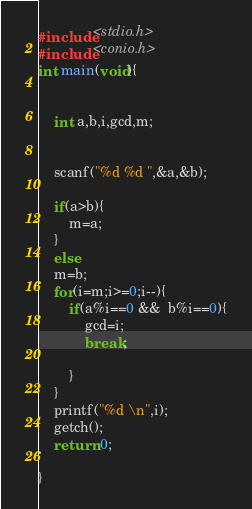<code> <loc_0><loc_0><loc_500><loc_500><_C_>#include<stdio.h>
#include<conio.h>
int main(void){
	
	
	int a,b,i,gcd,m;
	
	
	scanf("%d %d ",&a,&b);
	
	if(a>b){
		m=a;
	}
	else
	m=b;
	for(i=m;i>=0;i--){
		if(a%i==0 &&  b%i==0){
			gcd=i;
			break;
			
		}
	}
	printf("%d \n",i);
	getch();
	return 0;
	
}</code> 